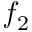<formula> <loc_0><loc_0><loc_500><loc_500>f _ { 2 }</formula> 